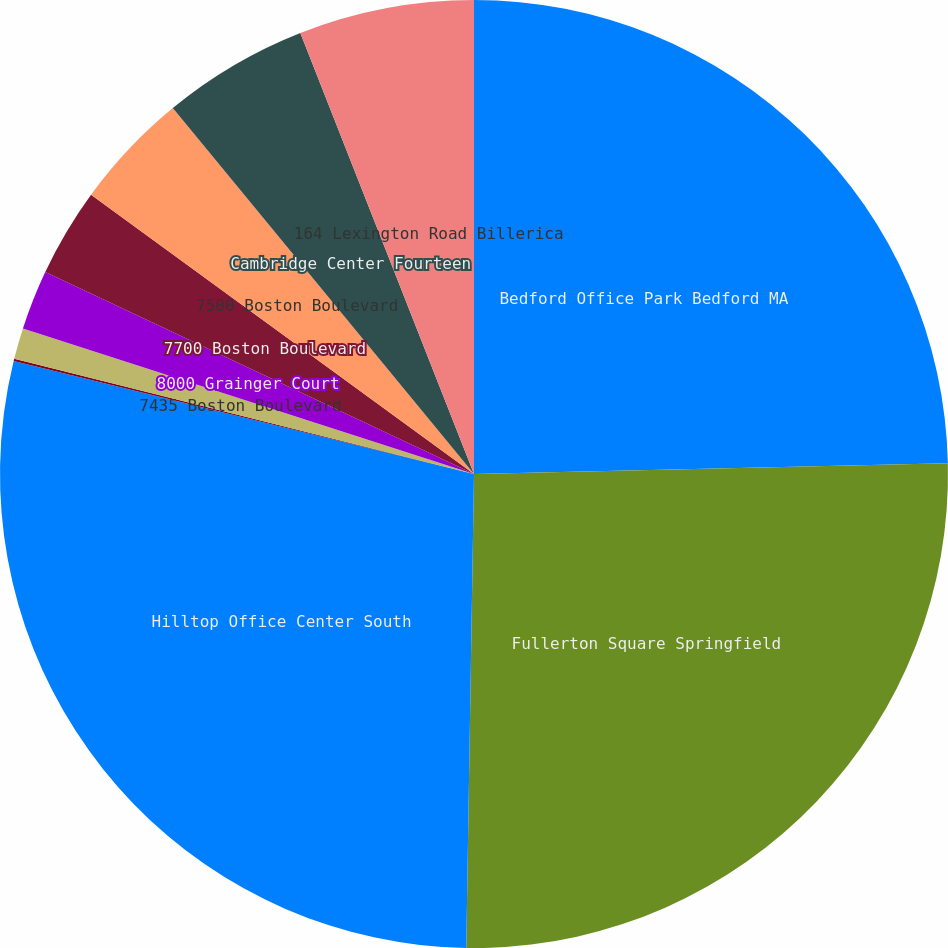Convert chart. <chart><loc_0><loc_0><loc_500><loc_500><pie_chart><fcel>Bedford Office Park Bedford MA<fcel>Fullerton Square Springfield<fcel>Hilltop Office Center South<fcel>7601 Boston Boulevard<fcel>7435 Boston Boulevard<fcel>8000 Grainger Court<fcel>7700 Boston Boulevard<fcel>7500 Boston Boulevard<fcel>Cambridge Center Fourteen<fcel>164 Lexington Road Billerica<nl><fcel>24.64%<fcel>25.62%<fcel>28.57%<fcel>0.08%<fcel>1.06%<fcel>2.04%<fcel>3.02%<fcel>4.01%<fcel>4.99%<fcel>5.97%<nl></chart> 